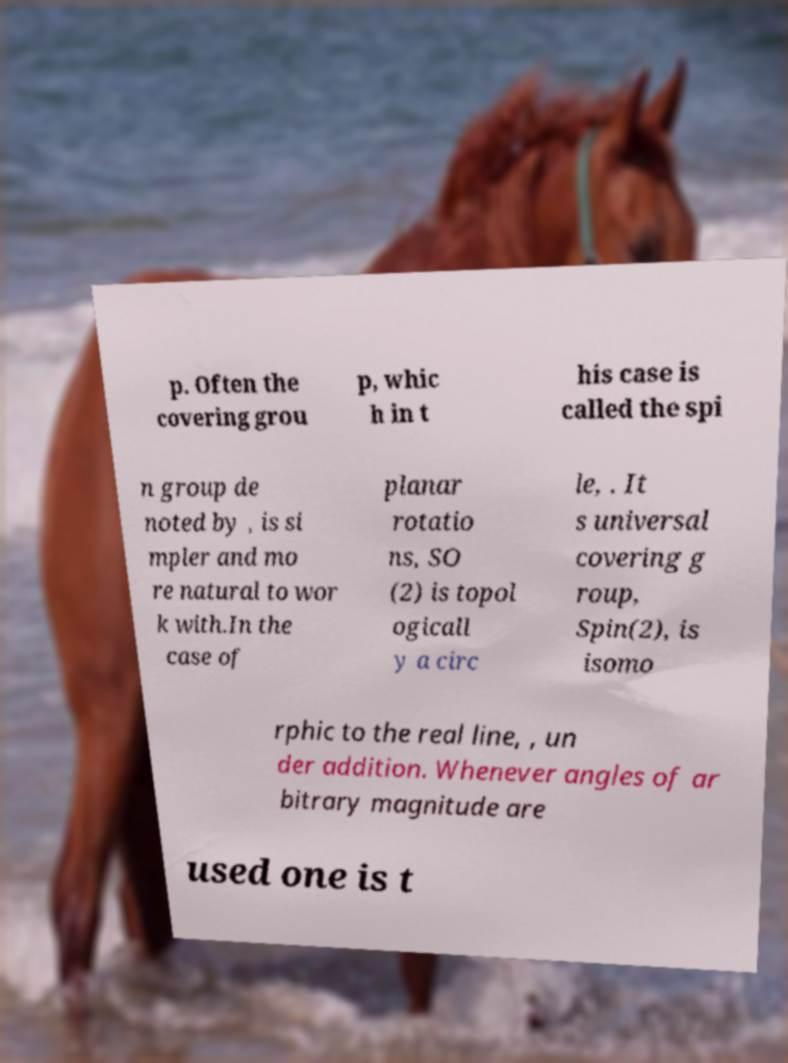Please read and relay the text visible in this image. What does it say? p. Often the covering grou p, whic h in t his case is called the spi n group de noted by , is si mpler and mo re natural to wor k with.In the case of planar rotatio ns, SO (2) is topol ogicall y a circ le, . It s universal covering g roup, Spin(2), is isomo rphic to the real line, , un der addition. Whenever angles of ar bitrary magnitude are used one is t 